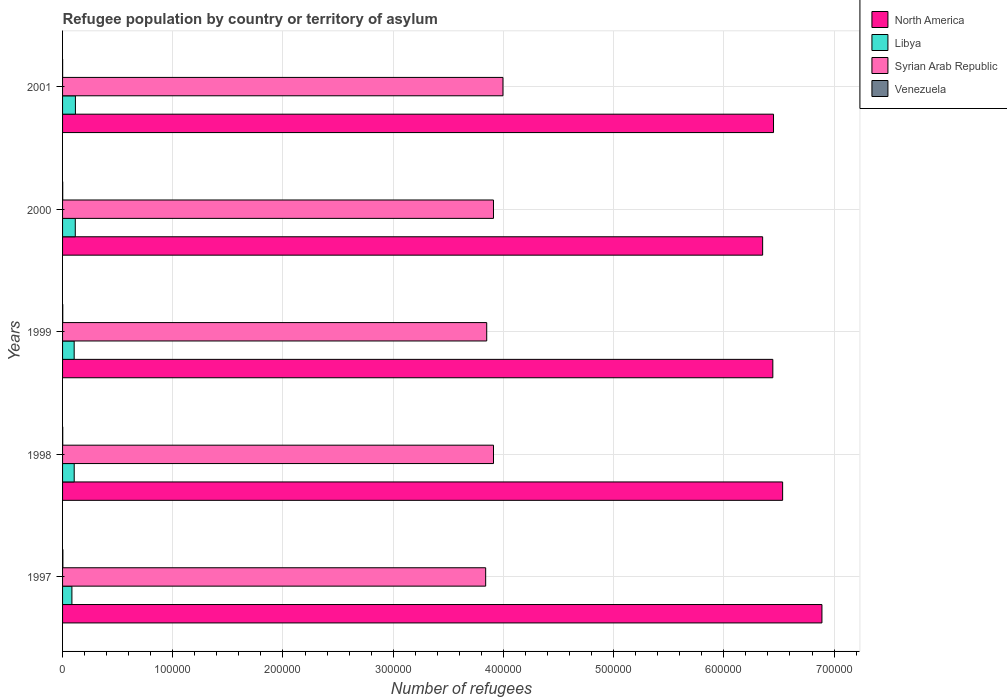Are the number of bars on each tick of the Y-axis equal?
Give a very brief answer. Yes. What is the label of the 2nd group of bars from the top?
Your answer should be compact. 2000. What is the number of refugees in Syrian Arab Republic in 1997?
Make the answer very short. 3.84e+05. Across all years, what is the maximum number of refugees in Libya?
Your answer should be very brief. 1.17e+04. Across all years, what is the minimum number of refugees in Syrian Arab Republic?
Offer a very short reply. 3.84e+05. In which year was the number of refugees in Syrian Arab Republic maximum?
Ensure brevity in your answer.  2001. What is the total number of refugees in Syrian Arab Republic in the graph?
Provide a short and direct response. 1.95e+06. What is the difference between the number of refugees in Syrian Arab Republic in 1999 and that in 2000?
Offer a terse response. -6133. What is the difference between the number of refugees in North America in 2000 and the number of refugees in Venezuela in 1998?
Offer a terse response. 6.35e+05. What is the average number of refugees in Libya per year?
Give a very brief answer. 1.06e+04. In the year 2000, what is the difference between the number of refugees in Libya and number of refugees in North America?
Your answer should be compact. -6.24e+05. What is the ratio of the number of refugees in Syrian Arab Republic in 1997 to that in 2000?
Offer a terse response. 0.98. Is the number of refugees in Venezuela in 1998 less than that in 2001?
Give a very brief answer. No. Is the difference between the number of refugees in Libya in 1998 and 2000 greater than the difference between the number of refugees in North America in 1998 and 2000?
Provide a succinct answer. No. What is the difference between the highest and the second highest number of refugees in Libya?
Offer a terse response. 121. What is the difference between the highest and the lowest number of refugees in North America?
Ensure brevity in your answer.  5.38e+04. In how many years, is the number of refugees in Libya greater than the average number of refugees in Libya taken over all years?
Your response must be concise. 3. Is the sum of the number of refugees in North America in 2000 and 2001 greater than the maximum number of refugees in Venezuela across all years?
Offer a very short reply. Yes. Is it the case that in every year, the sum of the number of refugees in North America and number of refugees in Syrian Arab Republic is greater than the sum of number of refugees in Venezuela and number of refugees in Libya?
Give a very brief answer. No. What does the 2nd bar from the top in 1998 represents?
Your response must be concise. Syrian Arab Republic. What does the 4th bar from the bottom in 1998 represents?
Keep it short and to the point. Venezuela. Is it the case that in every year, the sum of the number of refugees in Libya and number of refugees in Syrian Arab Republic is greater than the number of refugees in Venezuela?
Provide a short and direct response. Yes. Are all the bars in the graph horizontal?
Keep it short and to the point. Yes. What is the difference between two consecutive major ticks on the X-axis?
Your answer should be compact. 1.00e+05. Are the values on the major ticks of X-axis written in scientific E-notation?
Ensure brevity in your answer.  No. Does the graph contain grids?
Your response must be concise. Yes. Where does the legend appear in the graph?
Keep it short and to the point. Top right. What is the title of the graph?
Give a very brief answer. Refugee population by country or territory of asylum. What is the label or title of the X-axis?
Your response must be concise. Number of refugees. What is the label or title of the Y-axis?
Offer a very short reply. Years. What is the Number of refugees of North America in 1997?
Make the answer very short. 6.89e+05. What is the Number of refugees in Libya in 1997?
Keep it short and to the point. 8481. What is the Number of refugees of Syrian Arab Republic in 1997?
Make the answer very short. 3.84e+05. What is the Number of refugees in Venezuela in 1997?
Provide a short and direct response. 301. What is the Number of refugees of North America in 1998?
Make the answer very short. 6.53e+05. What is the Number of refugees in Libya in 1998?
Provide a short and direct response. 1.06e+04. What is the Number of refugees of Syrian Arab Republic in 1998?
Your answer should be very brief. 3.91e+05. What is the Number of refugees in Venezuela in 1998?
Keep it short and to the point. 158. What is the Number of refugees of North America in 1999?
Provide a succinct answer. 6.44e+05. What is the Number of refugees in Libya in 1999?
Your answer should be compact. 1.05e+04. What is the Number of refugees in Syrian Arab Republic in 1999?
Keep it short and to the point. 3.85e+05. What is the Number of refugees of Venezuela in 1999?
Keep it short and to the point. 188. What is the Number of refugees in North America in 2000?
Your answer should be compact. 6.35e+05. What is the Number of refugees in Libya in 2000?
Ensure brevity in your answer.  1.15e+04. What is the Number of refugees of Syrian Arab Republic in 2000?
Your answer should be compact. 3.91e+05. What is the Number of refugees in Venezuela in 2000?
Offer a very short reply. 132. What is the Number of refugees of North America in 2001?
Keep it short and to the point. 6.45e+05. What is the Number of refugees in Libya in 2001?
Provide a succinct answer. 1.17e+04. What is the Number of refugees in Syrian Arab Republic in 2001?
Offer a very short reply. 4.00e+05. Across all years, what is the maximum Number of refugees of North America?
Ensure brevity in your answer.  6.89e+05. Across all years, what is the maximum Number of refugees of Libya?
Your response must be concise. 1.17e+04. Across all years, what is the maximum Number of refugees in Syrian Arab Republic?
Keep it short and to the point. 4.00e+05. Across all years, what is the maximum Number of refugees in Venezuela?
Provide a short and direct response. 301. Across all years, what is the minimum Number of refugees of North America?
Your answer should be very brief. 6.35e+05. Across all years, what is the minimum Number of refugees of Libya?
Provide a short and direct response. 8481. Across all years, what is the minimum Number of refugees in Syrian Arab Republic?
Provide a succinct answer. 3.84e+05. Across all years, what is the minimum Number of refugees in Venezuela?
Keep it short and to the point. 59. What is the total Number of refugees in North America in the graph?
Your answer should be very brief. 3.27e+06. What is the total Number of refugees of Libya in the graph?
Your answer should be very brief. 5.28e+04. What is the total Number of refugees in Syrian Arab Republic in the graph?
Keep it short and to the point. 1.95e+06. What is the total Number of refugees in Venezuela in the graph?
Ensure brevity in your answer.  838. What is the difference between the Number of refugees in North America in 1997 and that in 1998?
Make the answer very short. 3.57e+04. What is the difference between the Number of refugees in Libya in 1997 and that in 1998?
Your answer should be compact. -2077. What is the difference between the Number of refugees of Syrian Arab Republic in 1997 and that in 1998?
Your answer should be very brief. -7103. What is the difference between the Number of refugees of Venezuela in 1997 and that in 1998?
Offer a very short reply. 143. What is the difference between the Number of refugees in North America in 1997 and that in 1999?
Your answer should be compact. 4.46e+04. What is the difference between the Number of refugees in Libya in 1997 and that in 1999?
Your response must be concise. -2054. What is the difference between the Number of refugees in Syrian Arab Republic in 1997 and that in 1999?
Your response must be concise. -950. What is the difference between the Number of refugees in Venezuela in 1997 and that in 1999?
Make the answer very short. 113. What is the difference between the Number of refugees in North America in 1997 and that in 2000?
Your response must be concise. 5.38e+04. What is the difference between the Number of refugees of Libya in 1997 and that in 2000?
Provide a succinct answer. -3062. What is the difference between the Number of refugees in Syrian Arab Republic in 1997 and that in 2000?
Ensure brevity in your answer.  -7083. What is the difference between the Number of refugees of Venezuela in 1997 and that in 2000?
Provide a short and direct response. 169. What is the difference between the Number of refugees in North America in 1997 and that in 2001?
Your response must be concise. 4.39e+04. What is the difference between the Number of refugees of Libya in 1997 and that in 2001?
Your response must be concise. -3183. What is the difference between the Number of refugees in Syrian Arab Republic in 1997 and that in 2001?
Ensure brevity in your answer.  -1.57e+04. What is the difference between the Number of refugees in Venezuela in 1997 and that in 2001?
Offer a very short reply. 242. What is the difference between the Number of refugees in North America in 1998 and that in 1999?
Your response must be concise. 8881. What is the difference between the Number of refugees in Libya in 1998 and that in 1999?
Give a very brief answer. 23. What is the difference between the Number of refugees of Syrian Arab Republic in 1998 and that in 1999?
Your answer should be compact. 6153. What is the difference between the Number of refugees in Venezuela in 1998 and that in 1999?
Your answer should be compact. -30. What is the difference between the Number of refugees of North America in 1998 and that in 2000?
Offer a very short reply. 1.81e+04. What is the difference between the Number of refugees in Libya in 1998 and that in 2000?
Offer a very short reply. -985. What is the difference between the Number of refugees of Syrian Arab Republic in 1998 and that in 2000?
Give a very brief answer. 20. What is the difference between the Number of refugees of Venezuela in 1998 and that in 2000?
Provide a succinct answer. 26. What is the difference between the Number of refugees in North America in 1998 and that in 2001?
Make the answer very short. 8263. What is the difference between the Number of refugees of Libya in 1998 and that in 2001?
Make the answer very short. -1106. What is the difference between the Number of refugees in Syrian Arab Republic in 1998 and that in 2001?
Offer a terse response. -8590. What is the difference between the Number of refugees in North America in 1999 and that in 2000?
Your answer should be compact. 9246. What is the difference between the Number of refugees of Libya in 1999 and that in 2000?
Keep it short and to the point. -1008. What is the difference between the Number of refugees in Syrian Arab Republic in 1999 and that in 2000?
Give a very brief answer. -6133. What is the difference between the Number of refugees of North America in 1999 and that in 2001?
Keep it short and to the point. -618. What is the difference between the Number of refugees in Libya in 1999 and that in 2001?
Your answer should be very brief. -1129. What is the difference between the Number of refugees of Syrian Arab Republic in 1999 and that in 2001?
Keep it short and to the point. -1.47e+04. What is the difference between the Number of refugees of Venezuela in 1999 and that in 2001?
Keep it short and to the point. 129. What is the difference between the Number of refugees of North America in 2000 and that in 2001?
Keep it short and to the point. -9864. What is the difference between the Number of refugees of Libya in 2000 and that in 2001?
Make the answer very short. -121. What is the difference between the Number of refugees of Syrian Arab Republic in 2000 and that in 2001?
Provide a short and direct response. -8610. What is the difference between the Number of refugees in North America in 1997 and the Number of refugees in Libya in 1998?
Offer a very short reply. 6.78e+05. What is the difference between the Number of refugees in North America in 1997 and the Number of refugees in Syrian Arab Republic in 1998?
Your answer should be compact. 2.98e+05. What is the difference between the Number of refugees of North America in 1997 and the Number of refugees of Venezuela in 1998?
Your answer should be compact. 6.89e+05. What is the difference between the Number of refugees of Libya in 1997 and the Number of refugees of Syrian Arab Republic in 1998?
Make the answer very short. -3.83e+05. What is the difference between the Number of refugees in Libya in 1997 and the Number of refugees in Venezuela in 1998?
Your answer should be very brief. 8323. What is the difference between the Number of refugees of Syrian Arab Republic in 1997 and the Number of refugees of Venezuela in 1998?
Your response must be concise. 3.84e+05. What is the difference between the Number of refugees of North America in 1997 and the Number of refugees of Libya in 1999?
Give a very brief answer. 6.78e+05. What is the difference between the Number of refugees of North America in 1997 and the Number of refugees of Syrian Arab Republic in 1999?
Keep it short and to the point. 3.04e+05. What is the difference between the Number of refugees of North America in 1997 and the Number of refugees of Venezuela in 1999?
Keep it short and to the point. 6.89e+05. What is the difference between the Number of refugees of Libya in 1997 and the Number of refugees of Syrian Arab Republic in 1999?
Ensure brevity in your answer.  -3.76e+05. What is the difference between the Number of refugees in Libya in 1997 and the Number of refugees in Venezuela in 1999?
Your answer should be compact. 8293. What is the difference between the Number of refugees in Syrian Arab Republic in 1997 and the Number of refugees in Venezuela in 1999?
Your answer should be very brief. 3.84e+05. What is the difference between the Number of refugees in North America in 1997 and the Number of refugees in Libya in 2000?
Offer a very short reply. 6.77e+05. What is the difference between the Number of refugees in North America in 1997 and the Number of refugees in Syrian Arab Republic in 2000?
Make the answer very short. 2.98e+05. What is the difference between the Number of refugees of North America in 1997 and the Number of refugees of Venezuela in 2000?
Your response must be concise. 6.89e+05. What is the difference between the Number of refugees in Libya in 1997 and the Number of refugees in Syrian Arab Republic in 2000?
Your answer should be compact. -3.83e+05. What is the difference between the Number of refugees in Libya in 1997 and the Number of refugees in Venezuela in 2000?
Make the answer very short. 8349. What is the difference between the Number of refugees in Syrian Arab Republic in 1997 and the Number of refugees in Venezuela in 2000?
Keep it short and to the point. 3.84e+05. What is the difference between the Number of refugees of North America in 1997 and the Number of refugees of Libya in 2001?
Your response must be concise. 6.77e+05. What is the difference between the Number of refugees of North America in 1997 and the Number of refugees of Syrian Arab Republic in 2001?
Give a very brief answer. 2.89e+05. What is the difference between the Number of refugees in North America in 1997 and the Number of refugees in Venezuela in 2001?
Ensure brevity in your answer.  6.89e+05. What is the difference between the Number of refugees in Libya in 1997 and the Number of refugees in Syrian Arab Republic in 2001?
Provide a short and direct response. -3.91e+05. What is the difference between the Number of refugees in Libya in 1997 and the Number of refugees in Venezuela in 2001?
Give a very brief answer. 8422. What is the difference between the Number of refugees in Syrian Arab Republic in 1997 and the Number of refugees in Venezuela in 2001?
Keep it short and to the point. 3.84e+05. What is the difference between the Number of refugees in North America in 1998 and the Number of refugees in Libya in 1999?
Offer a very short reply. 6.43e+05. What is the difference between the Number of refugees of North America in 1998 and the Number of refugees of Syrian Arab Republic in 1999?
Your answer should be very brief. 2.68e+05. What is the difference between the Number of refugees of North America in 1998 and the Number of refugees of Venezuela in 1999?
Keep it short and to the point. 6.53e+05. What is the difference between the Number of refugees of Libya in 1998 and the Number of refugees of Syrian Arab Republic in 1999?
Provide a succinct answer. -3.74e+05. What is the difference between the Number of refugees of Libya in 1998 and the Number of refugees of Venezuela in 1999?
Ensure brevity in your answer.  1.04e+04. What is the difference between the Number of refugees of Syrian Arab Republic in 1998 and the Number of refugees of Venezuela in 1999?
Keep it short and to the point. 3.91e+05. What is the difference between the Number of refugees in North America in 1998 and the Number of refugees in Libya in 2000?
Your answer should be very brief. 6.42e+05. What is the difference between the Number of refugees of North America in 1998 and the Number of refugees of Syrian Arab Republic in 2000?
Make the answer very short. 2.62e+05. What is the difference between the Number of refugees in North America in 1998 and the Number of refugees in Venezuela in 2000?
Make the answer very short. 6.53e+05. What is the difference between the Number of refugees in Libya in 1998 and the Number of refugees in Syrian Arab Republic in 2000?
Offer a terse response. -3.80e+05. What is the difference between the Number of refugees of Libya in 1998 and the Number of refugees of Venezuela in 2000?
Offer a terse response. 1.04e+04. What is the difference between the Number of refugees of Syrian Arab Republic in 1998 and the Number of refugees of Venezuela in 2000?
Offer a terse response. 3.91e+05. What is the difference between the Number of refugees of North America in 1998 and the Number of refugees of Libya in 2001?
Give a very brief answer. 6.42e+05. What is the difference between the Number of refugees in North America in 1998 and the Number of refugees in Syrian Arab Republic in 2001?
Make the answer very short. 2.54e+05. What is the difference between the Number of refugees of North America in 1998 and the Number of refugees of Venezuela in 2001?
Provide a succinct answer. 6.53e+05. What is the difference between the Number of refugees of Libya in 1998 and the Number of refugees of Syrian Arab Republic in 2001?
Your answer should be compact. -3.89e+05. What is the difference between the Number of refugees in Libya in 1998 and the Number of refugees in Venezuela in 2001?
Offer a very short reply. 1.05e+04. What is the difference between the Number of refugees of Syrian Arab Republic in 1998 and the Number of refugees of Venezuela in 2001?
Your response must be concise. 3.91e+05. What is the difference between the Number of refugees of North America in 1999 and the Number of refugees of Libya in 2000?
Keep it short and to the point. 6.33e+05. What is the difference between the Number of refugees of North America in 1999 and the Number of refugees of Syrian Arab Republic in 2000?
Provide a succinct answer. 2.53e+05. What is the difference between the Number of refugees in North America in 1999 and the Number of refugees in Venezuela in 2000?
Make the answer very short. 6.44e+05. What is the difference between the Number of refugees of Libya in 1999 and the Number of refugees of Syrian Arab Republic in 2000?
Your answer should be compact. -3.80e+05. What is the difference between the Number of refugees in Libya in 1999 and the Number of refugees in Venezuela in 2000?
Provide a succinct answer. 1.04e+04. What is the difference between the Number of refugees in Syrian Arab Republic in 1999 and the Number of refugees in Venezuela in 2000?
Your answer should be compact. 3.85e+05. What is the difference between the Number of refugees in North America in 1999 and the Number of refugees in Libya in 2001?
Give a very brief answer. 6.33e+05. What is the difference between the Number of refugees in North America in 1999 and the Number of refugees in Syrian Arab Republic in 2001?
Your answer should be compact. 2.45e+05. What is the difference between the Number of refugees in North America in 1999 and the Number of refugees in Venezuela in 2001?
Give a very brief answer. 6.44e+05. What is the difference between the Number of refugees in Libya in 1999 and the Number of refugees in Syrian Arab Republic in 2001?
Give a very brief answer. -3.89e+05. What is the difference between the Number of refugees in Libya in 1999 and the Number of refugees in Venezuela in 2001?
Your answer should be very brief. 1.05e+04. What is the difference between the Number of refugees in Syrian Arab Republic in 1999 and the Number of refugees in Venezuela in 2001?
Your answer should be very brief. 3.85e+05. What is the difference between the Number of refugees of North America in 2000 and the Number of refugees of Libya in 2001?
Provide a succinct answer. 6.24e+05. What is the difference between the Number of refugees of North America in 2000 and the Number of refugees of Syrian Arab Republic in 2001?
Your answer should be compact. 2.36e+05. What is the difference between the Number of refugees in North America in 2000 and the Number of refugees in Venezuela in 2001?
Your answer should be compact. 6.35e+05. What is the difference between the Number of refugees of Libya in 2000 and the Number of refugees of Syrian Arab Republic in 2001?
Provide a succinct answer. -3.88e+05. What is the difference between the Number of refugees in Libya in 2000 and the Number of refugees in Venezuela in 2001?
Give a very brief answer. 1.15e+04. What is the difference between the Number of refugees of Syrian Arab Republic in 2000 and the Number of refugees of Venezuela in 2001?
Your answer should be compact. 3.91e+05. What is the average Number of refugees in North America per year?
Your answer should be very brief. 6.53e+05. What is the average Number of refugees of Libya per year?
Keep it short and to the point. 1.06e+04. What is the average Number of refugees of Syrian Arab Republic per year?
Offer a terse response. 3.90e+05. What is the average Number of refugees of Venezuela per year?
Give a very brief answer. 167.6. In the year 1997, what is the difference between the Number of refugees of North America and Number of refugees of Libya?
Your answer should be very brief. 6.81e+05. In the year 1997, what is the difference between the Number of refugees of North America and Number of refugees of Syrian Arab Republic?
Your answer should be compact. 3.05e+05. In the year 1997, what is the difference between the Number of refugees in North America and Number of refugees in Venezuela?
Give a very brief answer. 6.89e+05. In the year 1997, what is the difference between the Number of refugees of Libya and Number of refugees of Syrian Arab Republic?
Your response must be concise. -3.75e+05. In the year 1997, what is the difference between the Number of refugees in Libya and Number of refugees in Venezuela?
Offer a very short reply. 8180. In the year 1997, what is the difference between the Number of refugees in Syrian Arab Republic and Number of refugees in Venezuela?
Make the answer very short. 3.84e+05. In the year 1998, what is the difference between the Number of refugees in North America and Number of refugees in Libya?
Give a very brief answer. 6.43e+05. In the year 1998, what is the difference between the Number of refugees of North America and Number of refugees of Syrian Arab Republic?
Keep it short and to the point. 2.62e+05. In the year 1998, what is the difference between the Number of refugees in North America and Number of refugees in Venezuela?
Your response must be concise. 6.53e+05. In the year 1998, what is the difference between the Number of refugees in Libya and Number of refugees in Syrian Arab Republic?
Offer a terse response. -3.80e+05. In the year 1998, what is the difference between the Number of refugees of Libya and Number of refugees of Venezuela?
Give a very brief answer. 1.04e+04. In the year 1998, what is the difference between the Number of refugees of Syrian Arab Republic and Number of refugees of Venezuela?
Your answer should be very brief. 3.91e+05. In the year 1999, what is the difference between the Number of refugees in North America and Number of refugees in Libya?
Offer a terse response. 6.34e+05. In the year 1999, what is the difference between the Number of refugees in North America and Number of refugees in Syrian Arab Republic?
Make the answer very short. 2.60e+05. In the year 1999, what is the difference between the Number of refugees in North America and Number of refugees in Venezuela?
Provide a succinct answer. 6.44e+05. In the year 1999, what is the difference between the Number of refugees of Libya and Number of refugees of Syrian Arab Republic?
Provide a succinct answer. -3.74e+05. In the year 1999, what is the difference between the Number of refugees in Libya and Number of refugees in Venezuela?
Offer a terse response. 1.03e+04. In the year 1999, what is the difference between the Number of refugees in Syrian Arab Republic and Number of refugees in Venezuela?
Give a very brief answer. 3.85e+05. In the year 2000, what is the difference between the Number of refugees in North America and Number of refugees in Libya?
Keep it short and to the point. 6.24e+05. In the year 2000, what is the difference between the Number of refugees of North America and Number of refugees of Syrian Arab Republic?
Make the answer very short. 2.44e+05. In the year 2000, what is the difference between the Number of refugees of North America and Number of refugees of Venezuela?
Provide a succinct answer. 6.35e+05. In the year 2000, what is the difference between the Number of refugees in Libya and Number of refugees in Syrian Arab Republic?
Provide a short and direct response. -3.79e+05. In the year 2000, what is the difference between the Number of refugees in Libya and Number of refugees in Venezuela?
Provide a succinct answer. 1.14e+04. In the year 2000, what is the difference between the Number of refugees in Syrian Arab Republic and Number of refugees in Venezuela?
Your answer should be very brief. 3.91e+05. In the year 2001, what is the difference between the Number of refugees in North America and Number of refugees in Libya?
Keep it short and to the point. 6.33e+05. In the year 2001, what is the difference between the Number of refugees in North America and Number of refugees in Syrian Arab Republic?
Provide a short and direct response. 2.45e+05. In the year 2001, what is the difference between the Number of refugees in North America and Number of refugees in Venezuela?
Keep it short and to the point. 6.45e+05. In the year 2001, what is the difference between the Number of refugees in Libya and Number of refugees in Syrian Arab Republic?
Your response must be concise. -3.88e+05. In the year 2001, what is the difference between the Number of refugees in Libya and Number of refugees in Venezuela?
Give a very brief answer. 1.16e+04. In the year 2001, what is the difference between the Number of refugees of Syrian Arab Republic and Number of refugees of Venezuela?
Give a very brief answer. 4.00e+05. What is the ratio of the Number of refugees of North America in 1997 to that in 1998?
Give a very brief answer. 1.05. What is the ratio of the Number of refugees of Libya in 1997 to that in 1998?
Your answer should be very brief. 0.8. What is the ratio of the Number of refugees in Syrian Arab Republic in 1997 to that in 1998?
Keep it short and to the point. 0.98. What is the ratio of the Number of refugees of Venezuela in 1997 to that in 1998?
Make the answer very short. 1.91. What is the ratio of the Number of refugees in North America in 1997 to that in 1999?
Your answer should be compact. 1.07. What is the ratio of the Number of refugees in Libya in 1997 to that in 1999?
Provide a succinct answer. 0.81. What is the ratio of the Number of refugees of Venezuela in 1997 to that in 1999?
Provide a short and direct response. 1.6. What is the ratio of the Number of refugees of North America in 1997 to that in 2000?
Make the answer very short. 1.08. What is the ratio of the Number of refugees in Libya in 1997 to that in 2000?
Provide a short and direct response. 0.73. What is the ratio of the Number of refugees in Syrian Arab Republic in 1997 to that in 2000?
Provide a succinct answer. 0.98. What is the ratio of the Number of refugees of Venezuela in 1997 to that in 2000?
Provide a short and direct response. 2.28. What is the ratio of the Number of refugees in North America in 1997 to that in 2001?
Offer a very short reply. 1.07. What is the ratio of the Number of refugees of Libya in 1997 to that in 2001?
Give a very brief answer. 0.73. What is the ratio of the Number of refugees of Syrian Arab Republic in 1997 to that in 2001?
Give a very brief answer. 0.96. What is the ratio of the Number of refugees of Venezuela in 1997 to that in 2001?
Offer a terse response. 5.1. What is the ratio of the Number of refugees of North America in 1998 to that in 1999?
Make the answer very short. 1.01. What is the ratio of the Number of refugees in Libya in 1998 to that in 1999?
Make the answer very short. 1. What is the ratio of the Number of refugees of Syrian Arab Republic in 1998 to that in 1999?
Offer a terse response. 1.02. What is the ratio of the Number of refugees of Venezuela in 1998 to that in 1999?
Offer a very short reply. 0.84. What is the ratio of the Number of refugees of North America in 1998 to that in 2000?
Ensure brevity in your answer.  1.03. What is the ratio of the Number of refugees in Libya in 1998 to that in 2000?
Give a very brief answer. 0.91. What is the ratio of the Number of refugees of Syrian Arab Republic in 1998 to that in 2000?
Make the answer very short. 1. What is the ratio of the Number of refugees of Venezuela in 1998 to that in 2000?
Your response must be concise. 1.2. What is the ratio of the Number of refugees in North America in 1998 to that in 2001?
Make the answer very short. 1.01. What is the ratio of the Number of refugees in Libya in 1998 to that in 2001?
Ensure brevity in your answer.  0.91. What is the ratio of the Number of refugees of Syrian Arab Republic in 1998 to that in 2001?
Make the answer very short. 0.98. What is the ratio of the Number of refugees in Venezuela in 1998 to that in 2001?
Your answer should be very brief. 2.68. What is the ratio of the Number of refugees in North America in 1999 to that in 2000?
Your response must be concise. 1.01. What is the ratio of the Number of refugees in Libya in 1999 to that in 2000?
Offer a very short reply. 0.91. What is the ratio of the Number of refugees of Syrian Arab Republic in 1999 to that in 2000?
Offer a terse response. 0.98. What is the ratio of the Number of refugees in Venezuela in 1999 to that in 2000?
Make the answer very short. 1.42. What is the ratio of the Number of refugees in Libya in 1999 to that in 2001?
Offer a very short reply. 0.9. What is the ratio of the Number of refugees of Syrian Arab Republic in 1999 to that in 2001?
Keep it short and to the point. 0.96. What is the ratio of the Number of refugees of Venezuela in 1999 to that in 2001?
Keep it short and to the point. 3.19. What is the ratio of the Number of refugees in North America in 2000 to that in 2001?
Give a very brief answer. 0.98. What is the ratio of the Number of refugees of Libya in 2000 to that in 2001?
Your response must be concise. 0.99. What is the ratio of the Number of refugees of Syrian Arab Republic in 2000 to that in 2001?
Your answer should be compact. 0.98. What is the ratio of the Number of refugees of Venezuela in 2000 to that in 2001?
Provide a succinct answer. 2.24. What is the difference between the highest and the second highest Number of refugees of North America?
Offer a terse response. 3.57e+04. What is the difference between the highest and the second highest Number of refugees in Libya?
Keep it short and to the point. 121. What is the difference between the highest and the second highest Number of refugees in Syrian Arab Republic?
Your answer should be compact. 8590. What is the difference between the highest and the second highest Number of refugees of Venezuela?
Your answer should be compact. 113. What is the difference between the highest and the lowest Number of refugees in North America?
Provide a succinct answer. 5.38e+04. What is the difference between the highest and the lowest Number of refugees of Libya?
Ensure brevity in your answer.  3183. What is the difference between the highest and the lowest Number of refugees of Syrian Arab Republic?
Make the answer very short. 1.57e+04. What is the difference between the highest and the lowest Number of refugees of Venezuela?
Your response must be concise. 242. 